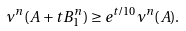<formula> <loc_0><loc_0><loc_500><loc_500>\nu ^ { n } ( A + t B _ { 1 } ^ { n } ) \geq e ^ { t \slash 1 0 } \nu ^ { n } ( A ) .</formula> 